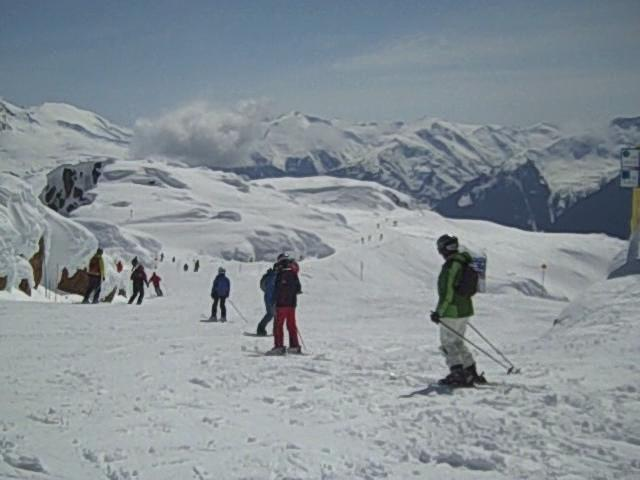What season brings this weather? Please explain your reasoning. winter. The ground is covered in snow. 